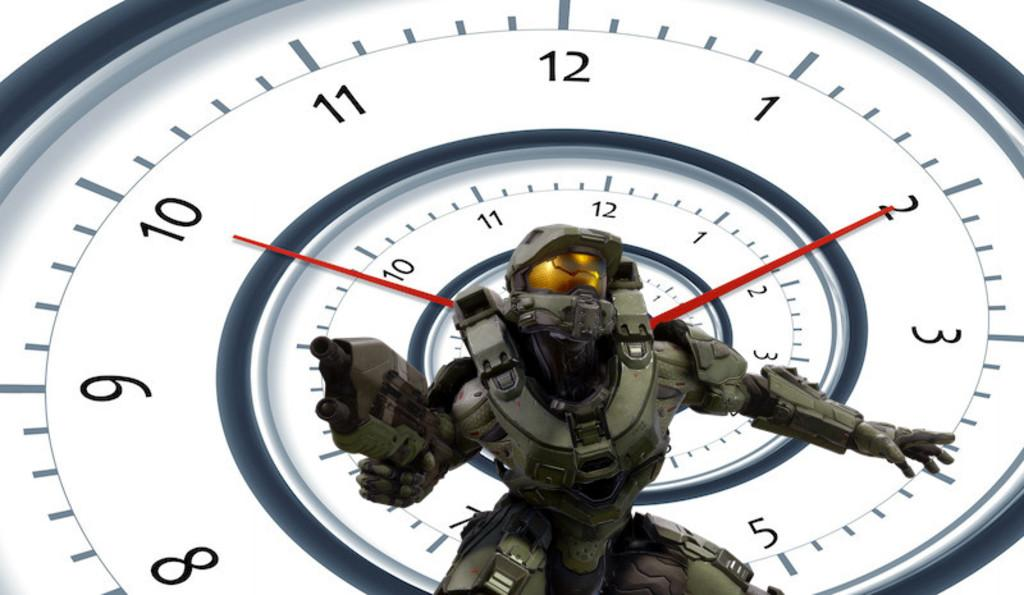<image>
Share a concise interpretation of the image provided. An action figure is in front of a spiraled wall clock that reads the time 2:50. 